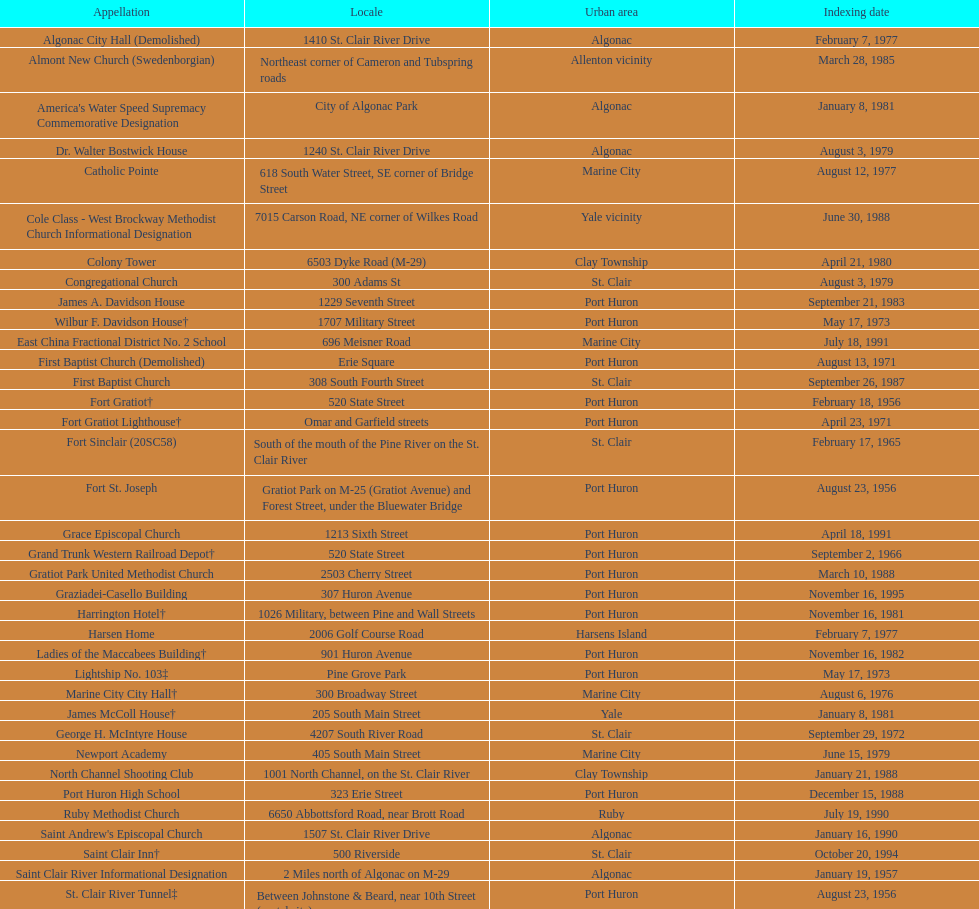What is the total number of locations in the city of algonac? 5. 